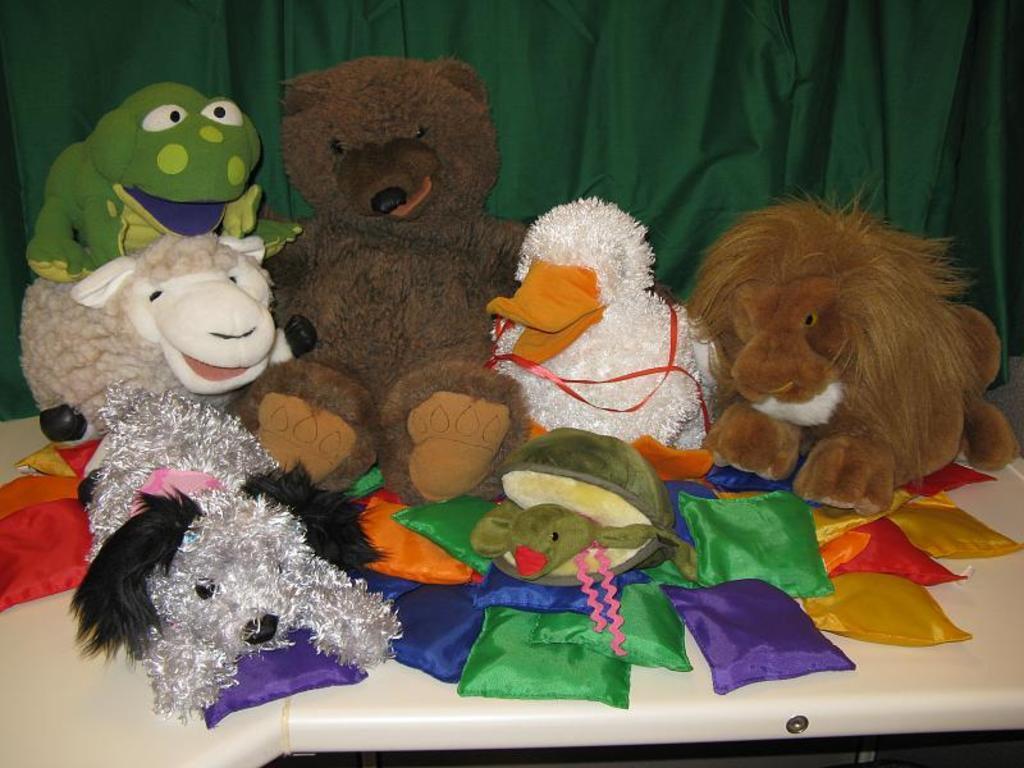Can you describe this image briefly? In the background portion of the picture we can see a green cloth. We can see different toys on a platform. 